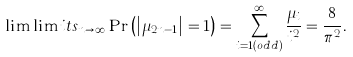Convert formula to latex. <formula><loc_0><loc_0><loc_500><loc_500>\lim \lim i t s _ { n \to \infty } \Pr \left ( \left | \mu _ { 2 n - 1 } \right | = 1 \right ) = \sum _ { i = 1 \left ( o d d \right ) } ^ { \infty } \frac { \mu _ { i } } { i ^ { 2 } } = \frac { 8 } { \pi ^ { 2 } } .</formula> 